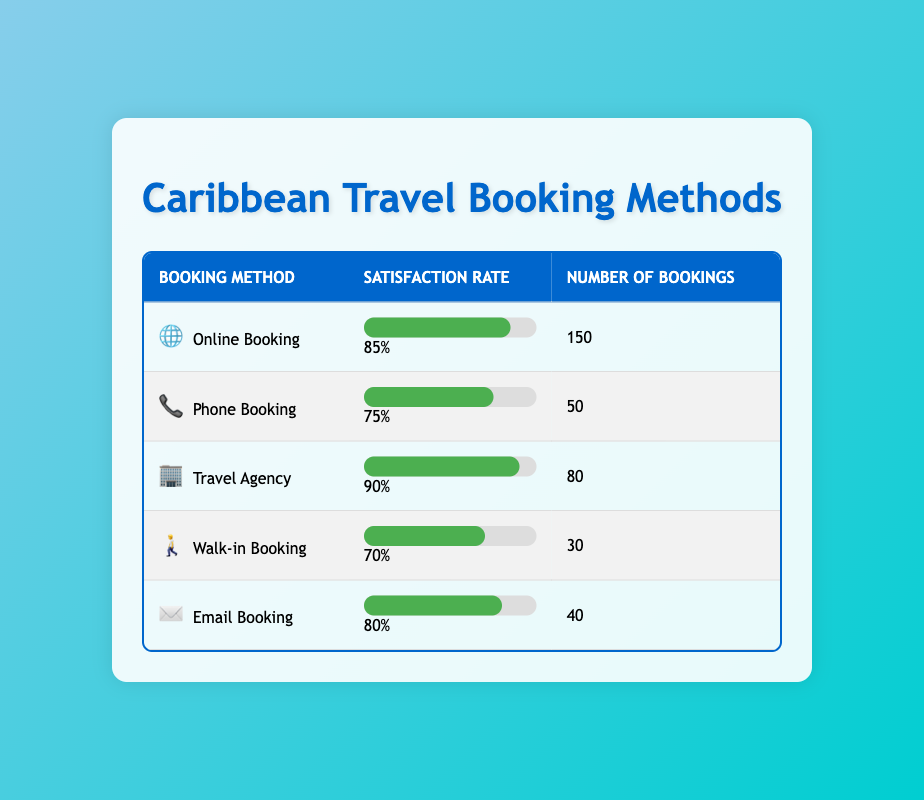What is the satisfaction rate for Online Booking? The satisfaction rate for Online Booking is directly listed in the table under the "Satisfaction Rate" column for that specific booking method. It shows 85%.
Answer: 85% How many bookings were made via Phone Booking? The number of bookings for Phone Booking can be found in the table where it lists "Number of Bookings" for that method, which shows 50.
Answer: 50 Which booking method has the highest satisfaction rate? By comparing the satisfaction rates listed for each booking method, Travel Agency has the highest rate at 90%, which is greater than the rates of all other methods.
Answer: Travel Agency What is the average satisfaction rate for all booking methods? To find the average satisfaction rate, we sum the satisfaction rates: 85 + 75 + 90 + 70 + 80 = 400. Then we divide by the number of methods (5). So, 400 / 5 = 80.
Answer: 80 Is the satisfaction rate for Email Booking higher than that for Walk-in Booking? The satisfaction rate for Email Booking is 80%, while for Walk-in Booking it is 70%. Since 80% is greater than 70%, the statement is true.
Answer: Yes What is the total number of bookings made across all methods? To find the total number of bookings, we sum the values in the "Number of Bookings" column: 150 + 50 + 80 + 30 + 40 = 350.
Answer: 350 Is there a booking method with a satisfaction rate below 75%? If we check the satisfaction rates of the booking methods, Phone Booking (75%) and Walk-in Booking (70%) both fall below, or are at, 75%. Therefore, the answer is yes.
Answer: Yes What is the difference in satisfaction rate between the Travel Agency and Phone Booking? The satisfaction rate for the Travel Agency is 90%. For Phone Booking, it is 75%. The difference is 90 - 75 = 15.
Answer: 15 What percentage of the total bookings were made through Online Booking? The total number of bookings is 350. Online Booking has 150 bookings. To find the percentage, we calculate (150 / 350) * 100, which is approximately 42.86%.
Answer: 42.86% 